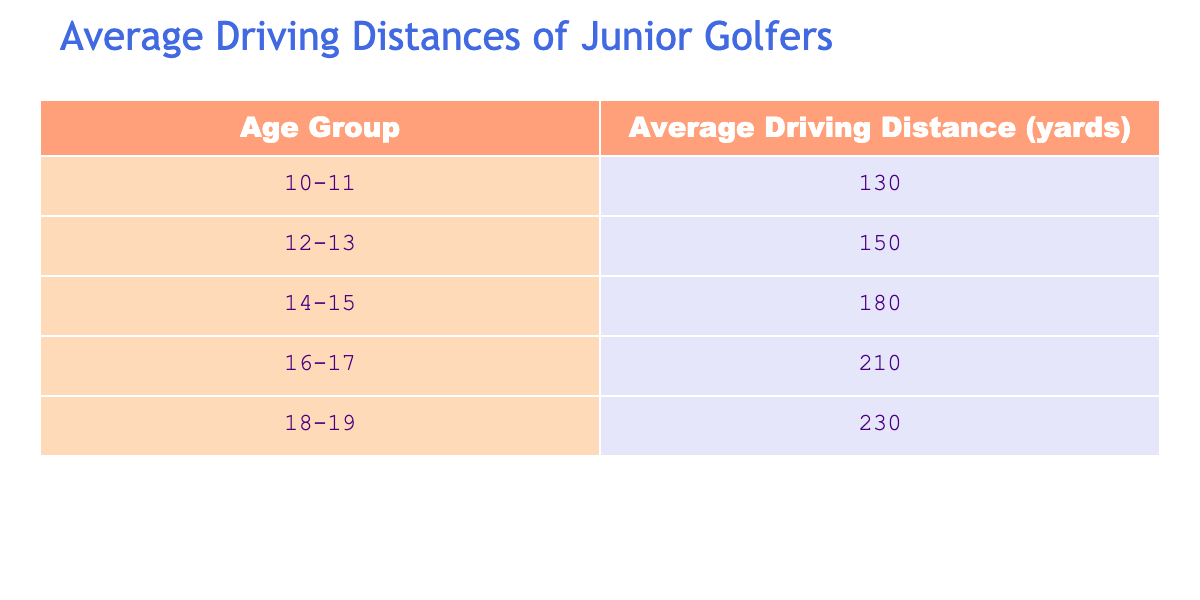What is the average driving distance for the age group 14-15? The table shows that the average driving distance for the age group 14-15 is listed directly as 180 yards.
Answer: 180 Which age group has the highest average driving distance? The age group 18-19 has the highest average driving distance at 230 yards. This value is compared with all other age groups listed in the table.
Answer: 18-19 What is the difference in average driving distance between age groups 12-13 and 16-17? For age group 12-13, the average is 150 yards, and for group 16-17, it is 210 yards. The difference is calculated as 210 - 150 = 60 yards.
Answer: 60 Is it true that the average driving distance increases as the age group increases? By comparing the average driving distances across all age groups, we can see a consistent increase: 130, 150, 180, 210, and 230. Thus, it is true that the average driving distance increases with age.
Answer: Yes What is the average of the average driving distances of all the age groups combined? The sum of average driving distances is 130 + 150 + 180 + 210 + 230 = 1100 yards. There are 5 age groups, so the average is 1100 / 5 = 220 yards.
Answer: 220 Which age group has an average driving distance closest to 200 yards? The age group 16-17 has an average driving distance of 210 yards, while 14-15 has 180 yards. Since 210 and 180 are the closest to 200, we consider the age group 16-17.
Answer: 16-17 What is the total average driving distance of the age groups 10-11 and 18-19 combined? The average for 10-11 is 130 yards, and for 18-19, it is 230 yards. Adding these values gives 130 + 230 = 360 yards for the combined average.
Answer: 360 Which age group has an average driving distance below 150 yards? By reviewing the table, the only age group with an average driving distance below 150 yards is 10-11, which has an average of 130 yards.
Answer: 10-11 